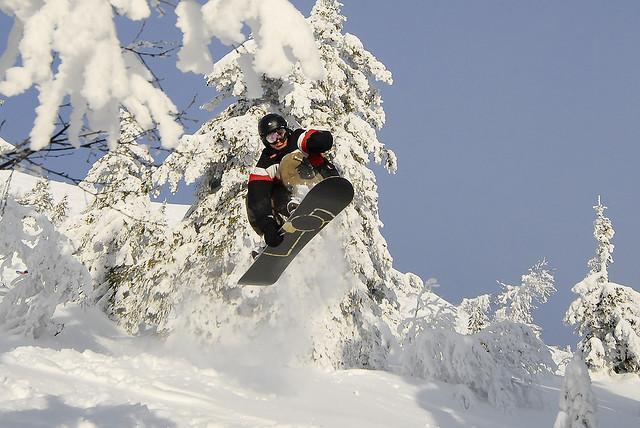How many snowboards are in the photo?
Give a very brief answer. 1. How many zebra near from tree?
Give a very brief answer. 0. 